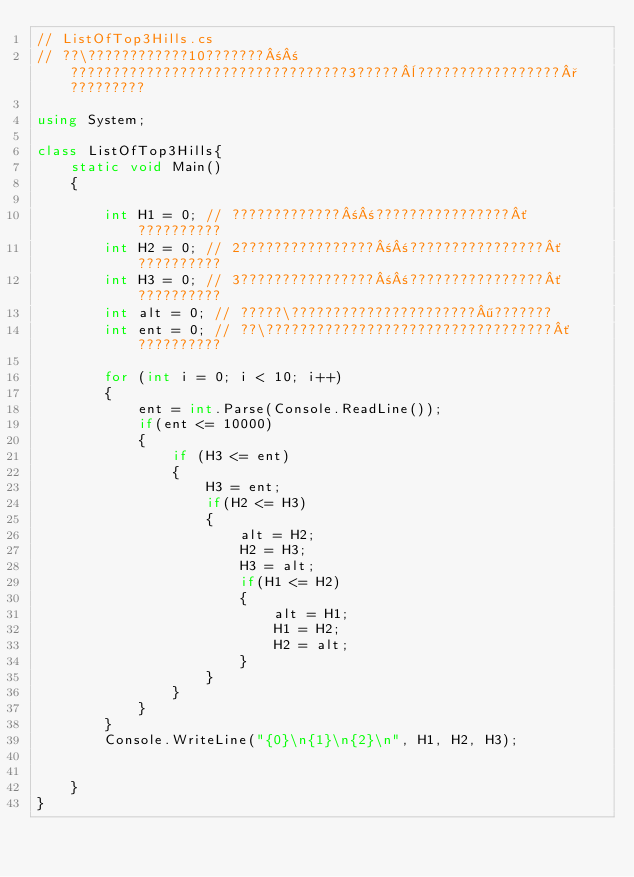Convert code to text. <code><loc_0><loc_0><loc_500><loc_500><_C#_>// ListOfTop3Hills.cs
// ??\????????????10???????±±?????????????????????????????????3?????¨?????????????????°?????????

using System;

class ListOfTop3Hills{
    static void Main()
    {
        
        int H1 = 0; // ?????????????±±????????????????´??????????
        int H2 = 0; // 2????????????????±±????????????????´??????????
        int H3 = 0; // 3????????????????±±????????????????´??????????
        int alt = 0; // ?????\??????????????????????¶???????
        int ent = 0; // ??\??????????????????????????????????´??????????
        
        for (int i = 0; i < 10; i++)
        {
            ent = int.Parse(Console.ReadLine());
            if(ent <= 10000)
            {
                if (H3 <= ent)
                {
                    H3 = ent;
                    if(H2 <= H3)
                    {
                        alt = H2;
                        H2 = H3;
                        H3 = alt;
                        if(H1 <= H2)
                        {
                            alt = H1;
                            H1 = H2;
                            H2 = alt;
                        }
                    }
                }
            }
        }
        Console.WriteLine("{0}\n{1}\n{2}\n", H1, H2, H3);
        
        
    }
}</code> 